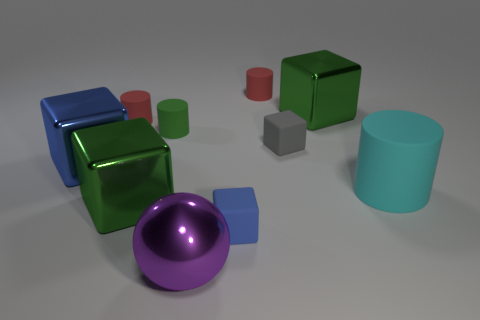Subtract all small matte cylinders. How many cylinders are left? 1 Subtract all spheres. How many objects are left? 9 Subtract all purple blocks. How many red cylinders are left? 2 Subtract all blue blocks. How many blocks are left? 3 Subtract 0 yellow cylinders. How many objects are left? 10 Subtract 4 blocks. How many blocks are left? 1 Subtract all green blocks. Subtract all red cylinders. How many blocks are left? 3 Subtract all big purple metallic balls. Subtract all gray rubber blocks. How many objects are left? 8 Add 4 red matte cylinders. How many red matte cylinders are left? 6 Add 8 small blue matte cubes. How many small blue matte cubes exist? 9 